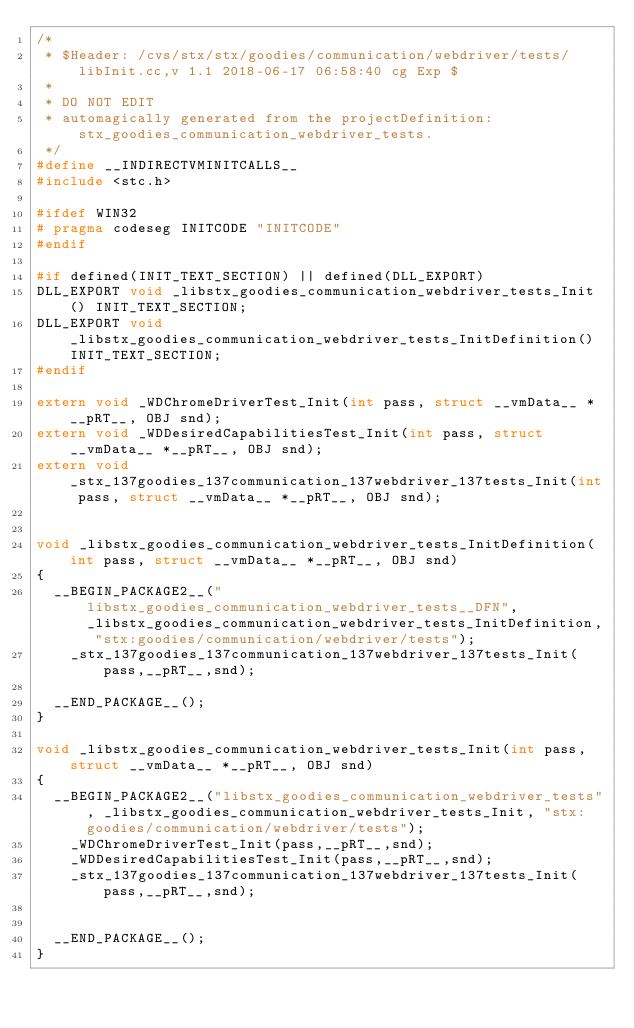Convert code to text. <code><loc_0><loc_0><loc_500><loc_500><_C++_>/*
 * $Header: /cvs/stx/stx/goodies/communication/webdriver/tests/libInit.cc,v 1.1 2018-06-17 06:58:40 cg Exp $
 *
 * DO NOT EDIT
 * automagically generated from the projectDefinition: stx_goodies_communication_webdriver_tests.
 */
#define __INDIRECTVMINITCALLS__
#include <stc.h>

#ifdef WIN32
# pragma codeseg INITCODE "INITCODE"
#endif

#if defined(INIT_TEXT_SECTION) || defined(DLL_EXPORT)
DLL_EXPORT void _libstx_goodies_communication_webdriver_tests_Init() INIT_TEXT_SECTION;
DLL_EXPORT void _libstx_goodies_communication_webdriver_tests_InitDefinition() INIT_TEXT_SECTION;
#endif

extern void _WDChromeDriverTest_Init(int pass, struct __vmData__ *__pRT__, OBJ snd);
extern void _WDDesiredCapabilitiesTest_Init(int pass, struct __vmData__ *__pRT__, OBJ snd);
extern void _stx_137goodies_137communication_137webdriver_137tests_Init(int pass, struct __vmData__ *__pRT__, OBJ snd);


void _libstx_goodies_communication_webdriver_tests_InitDefinition(int pass, struct __vmData__ *__pRT__, OBJ snd)
{
  __BEGIN_PACKAGE2__("libstx_goodies_communication_webdriver_tests__DFN", _libstx_goodies_communication_webdriver_tests_InitDefinition, "stx:goodies/communication/webdriver/tests");
    _stx_137goodies_137communication_137webdriver_137tests_Init(pass,__pRT__,snd);

  __END_PACKAGE__();
}

void _libstx_goodies_communication_webdriver_tests_Init(int pass, struct __vmData__ *__pRT__, OBJ snd)
{
  __BEGIN_PACKAGE2__("libstx_goodies_communication_webdriver_tests", _libstx_goodies_communication_webdriver_tests_Init, "stx:goodies/communication/webdriver/tests");
    _WDChromeDriverTest_Init(pass,__pRT__,snd);
    _WDDesiredCapabilitiesTest_Init(pass,__pRT__,snd);
    _stx_137goodies_137communication_137webdriver_137tests_Init(pass,__pRT__,snd);


  __END_PACKAGE__();
}
</code> 